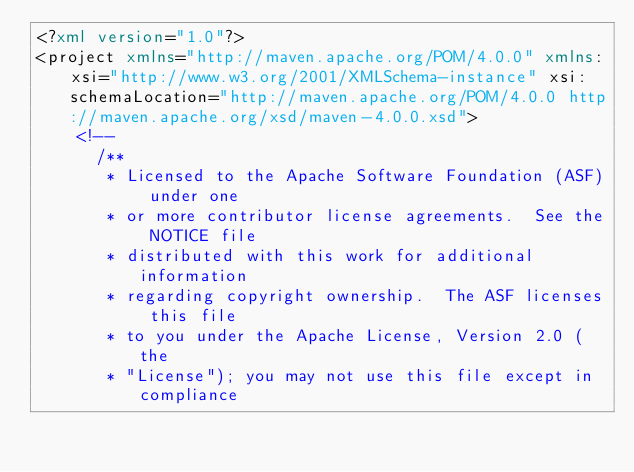<code> <loc_0><loc_0><loc_500><loc_500><_XML_><?xml version="1.0"?>
<project xmlns="http://maven.apache.org/POM/4.0.0" xmlns:xsi="http://www.w3.org/2001/XMLSchema-instance" xsi:schemaLocation="http://maven.apache.org/POM/4.0.0 http://maven.apache.org/xsd/maven-4.0.0.xsd">
    <!--
      /**
       * Licensed to the Apache Software Foundation (ASF) under one
       * or more contributor license agreements.  See the NOTICE file
       * distributed with this work for additional information
       * regarding copyright ownership.  The ASF licenses this file
       * to you under the Apache License, Version 2.0 (the
       * "License"); you may not use this file except in compliance</code> 